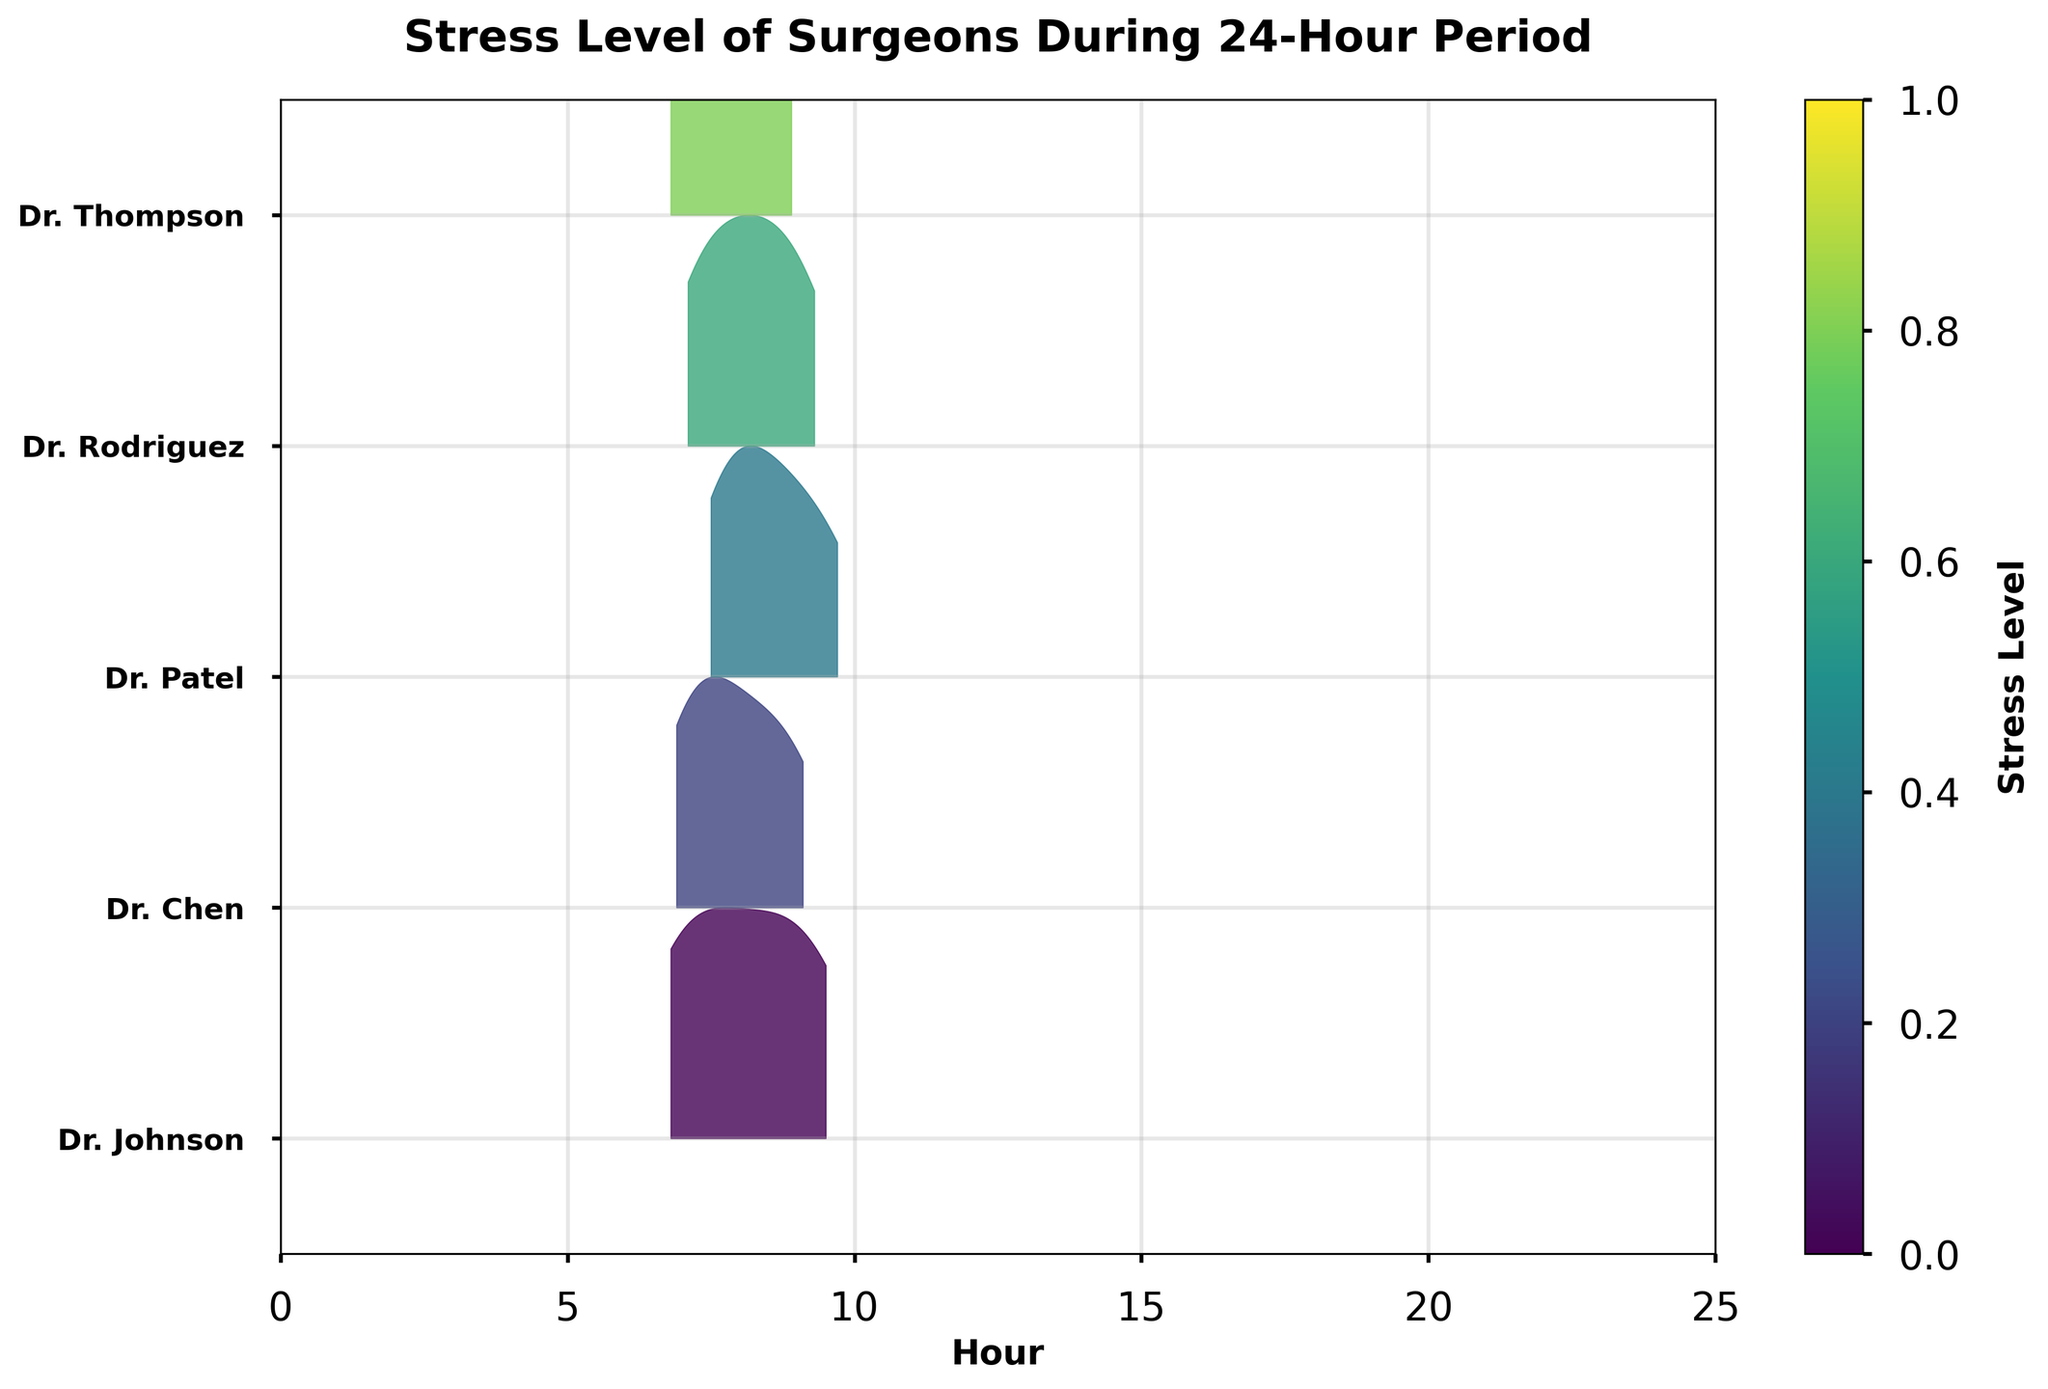Which surgeon has the highest stress level at the 24-hour mark? We need to check the stress levels for each surgeon at the 24-hour point. The values are as follows: Dr. Johnson (9.5), Dr. Chen (9.1), Dr. Patel (9.7), Dr. Rodriguez (9.3), Dr. Thompson (8.9). Dr. Patel has the highest stress level.
Answer: Dr. Patel How does Dr. Thompson's stress level at the 12-hour mark compare to his stress level at the 24-hour mark? Dr. Thompson's stress levels are 7.7 at the 12-hour mark and 8.9 at the 24-hour mark. We compare these two values: 8.9 is greater than 7.7.
Answer: 8.9 is higher than 7.7 What trend is observed in the stress levels of Dr. Johnson over the 24-hour period? We observe the stress levels of Dr. Johnson at 1, 6, 12, 18, and 24 hours, which are 7.2, 6.8, 8.1, 8.9, and 9.5 respectively. The trend shows a general increase over time.
Answer: Increasing trend Which surgeon starts with the lowest initial stress level and what is that level? We need to compare the stress levels at the 1-hour mark: Dr. Johnson (7.2), Dr. Chen (6.9), Dr. Patel (7.5), Dr. Rodriguez (7.1), Dr. Thompson (6.8). Dr. Thompson has the lowest initial stress level at 6.8.
Answer: Dr. Thompson, 6.8 On average, how does the stress level change between the 1-hour mark and the 24-hour mark for all surgeons? First, calculate the change in stress level for each surgeon between the 1-hour and 24-hour marks: Dr. Johnson (2.3), Dr. Chen (2.2), Dr. Patel (2.2), Dr. Rodriguez (2.2), Dr. Thompson (2.1). The average change is calculated as (2.3+2.2+2.2+2.2+2.1)/5 = 2.2.
Answer: 2.2 What is the general shape of Dr. Chen's stress level distribution over the 24-hour period as shown in the ridgeline plot? The stress levels for Dr. Chen are 6.9, 7.3, 7.8, 8.5, and 9.1. The ridgeline plot typically represents the density of these values. Dr. Chen's distribution will show a bell-shaped curve, concentrated around the higher end as the stress levels increase over time.
Answer: Bell-shaped Which surgeon has the highest concentration of stress around the middle of the 24-hour period? By examining the KDE peaks on the ridgeline plot around 12 hours, we see Dr. Patel has a notable concentration (8.4), indicating a high stress level mid-period.
Answer: Dr. Patel Among all the stress levels recorded at 6 hours, which surgeon has the highest stress level? Check the stress levels at the 6-hour mark: Dr. Johnson (6.8), Dr. Chen (7.3), Dr. Patel (7.9), Dr. Rodriguez (7.6), Dr. Thompson (7.2). Dr. Patel has the highest stress level at the 6-hour mark.
Answer: Dr. Patel 